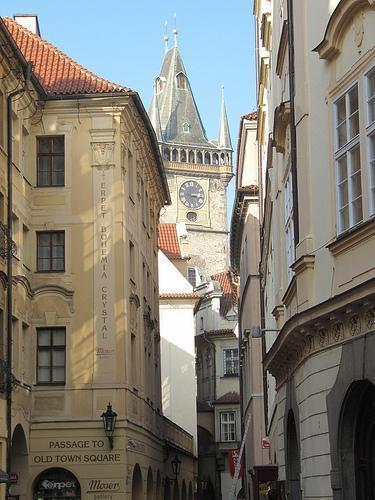How many clocks are in the photo?
Give a very brief answer. 1. How many lights are on top of the door in the lower left hand side of the photo?
Give a very brief answer. 1. 